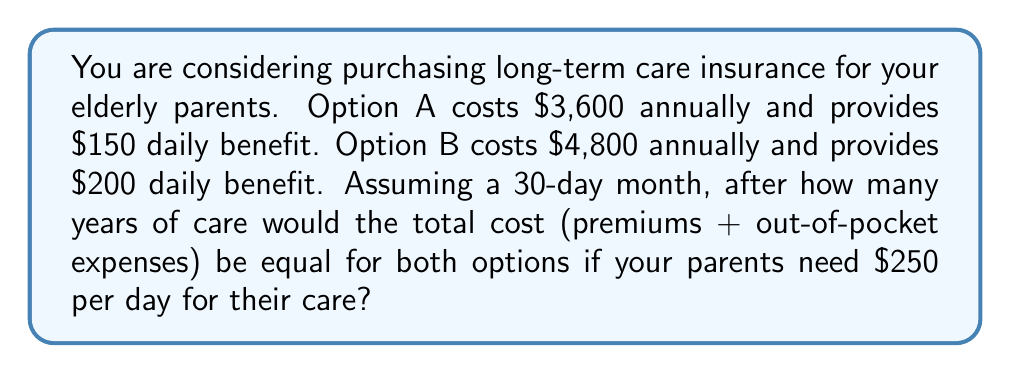Can you answer this question? Let's approach this step-by-step:

1) First, let's calculate the daily out-of-pocket expenses for each option:
   Option A: $250 - $150 = $100 per day
   Option B: $250 - $200 = $50 per day

2) Now, let's calculate the monthly out-of-pocket expenses:
   Option A: $100 * 30 = $3,000 per month
   Option B: $50 * 30 = $1,500 per month

3) Let's define x as the number of years. We can set up an equation where the total costs are equal:

   $$(3600 * x) + (3000 * 12 * x) = (4800 * x) + (1500 * 12 * x)$$

4) Simplify the equation:

   $$3600x + 36000x = 4800x + 18000x$$
   $$39600x = 22800x$$

5) Subtract 22800x from both sides:

   $$16800x = 0$$

6) Divide both sides by 16800:

   $$x = 0$$

7) Since x = 0 is not a meaningful answer in this context, we need to interpret this result. It means that the total costs are never equal. One option is always cheaper than the other.

8) To determine which option is cheaper, let's calculate the total annual cost for each:
   Option A: $3,600 + (3,000 * 12) = $39,600
   Option B: $4,800 + (1,500 * 12) = $22,800

9) Option B is always cheaper, regardless of the number of years.
Answer: Option B is always cheaper; there is no break-even point. 